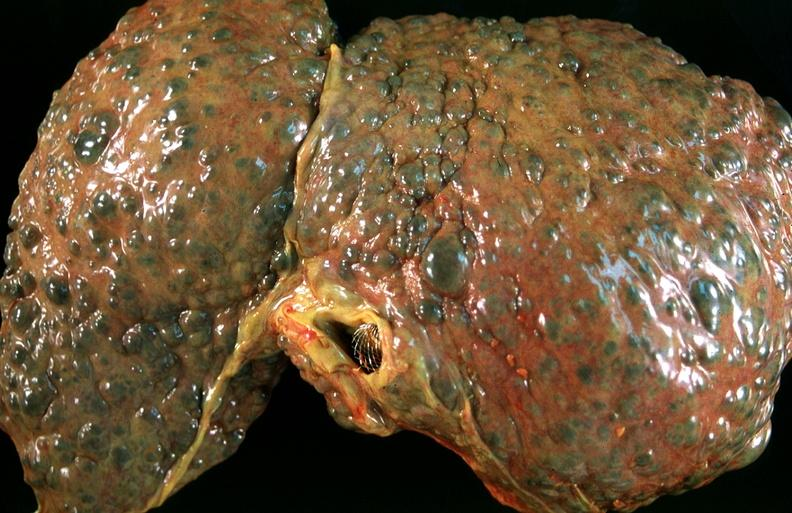what does this image show?
Answer the question using a single word or phrase. Liver 